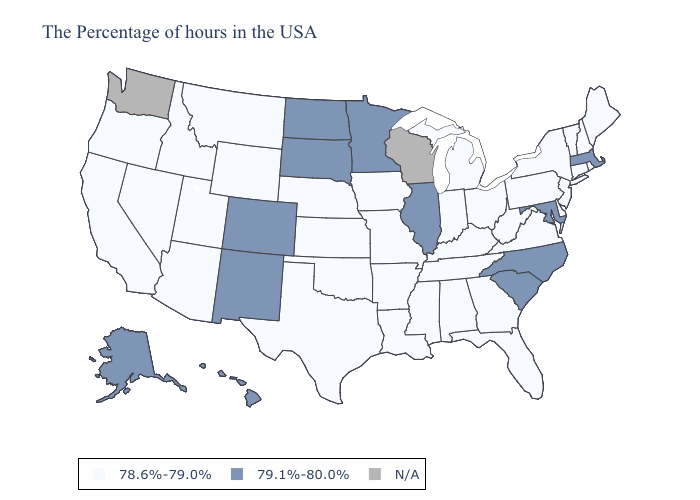Is the legend a continuous bar?
Quick response, please. No. Name the states that have a value in the range 78.6%-79.0%?
Quick response, please. Maine, Rhode Island, New Hampshire, Vermont, Connecticut, New York, New Jersey, Delaware, Pennsylvania, Virginia, West Virginia, Ohio, Florida, Georgia, Michigan, Kentucky, Indiana, Alabama, Tennessee, Mississippi, Louisiana, Missouri, Arkansas, Iowa, Kansas, Nebraska, Oklahoma, Texas, Wyoming, Utah, Montana, Arizona, Idaho, Nevada, California, Oregon. Does New Jersey have the highest value in the Northeast?
Concise answer only. No. Among the states that border Wyoming , does Idaho have the highest value?
Keep it brief. No. Does Alaska have the highest value in the USA?
Write a very short answer. Yes. What is the value of Delaware?
Answer briefly. 78.6%-79.0%. What is the value of Maryland?
Quick response, please. 79.1%-80.0%. Name the states that have a value in the range 79.1%-80.0%?
Short answer required. Massachusetts, Maryland, North Carolina, South Carolina, Illinois, Minnesota, South Dakota, North Dakota, Colorado, New Mexico, Alaska, Hawaii. What is the value of Utah?
Short answer required. 78.6%-79.0%. What is the highest value in the Northeast ?
Be succinct. 79.1%-80.0%. What is the value of Vermont?
Concise answer only. 78.6%-79.0%. What is the value of Wyoming?
Concise answer only. 78.6%-79.0%. Does the first symbol in the legend represent the smallest category?
Keep it brief. Yes. Does Alaska have the lowest value in the USA?
Write a very short answer. No. 